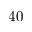<formula> <loc_0><loc_0><loc_500><loc_500>4 0</formula> 